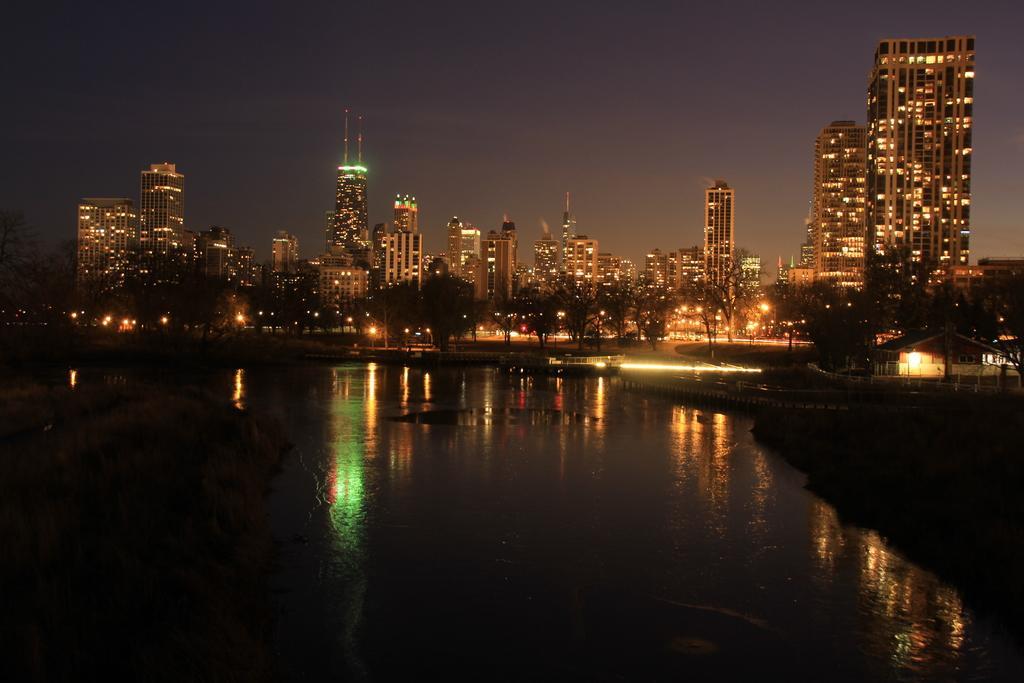Please provide a concise description of this image. At the bottom of the image there is water. Behind the water there are many trees and lights. Also there are buildings with lights. At the top of the image there is a sky. 